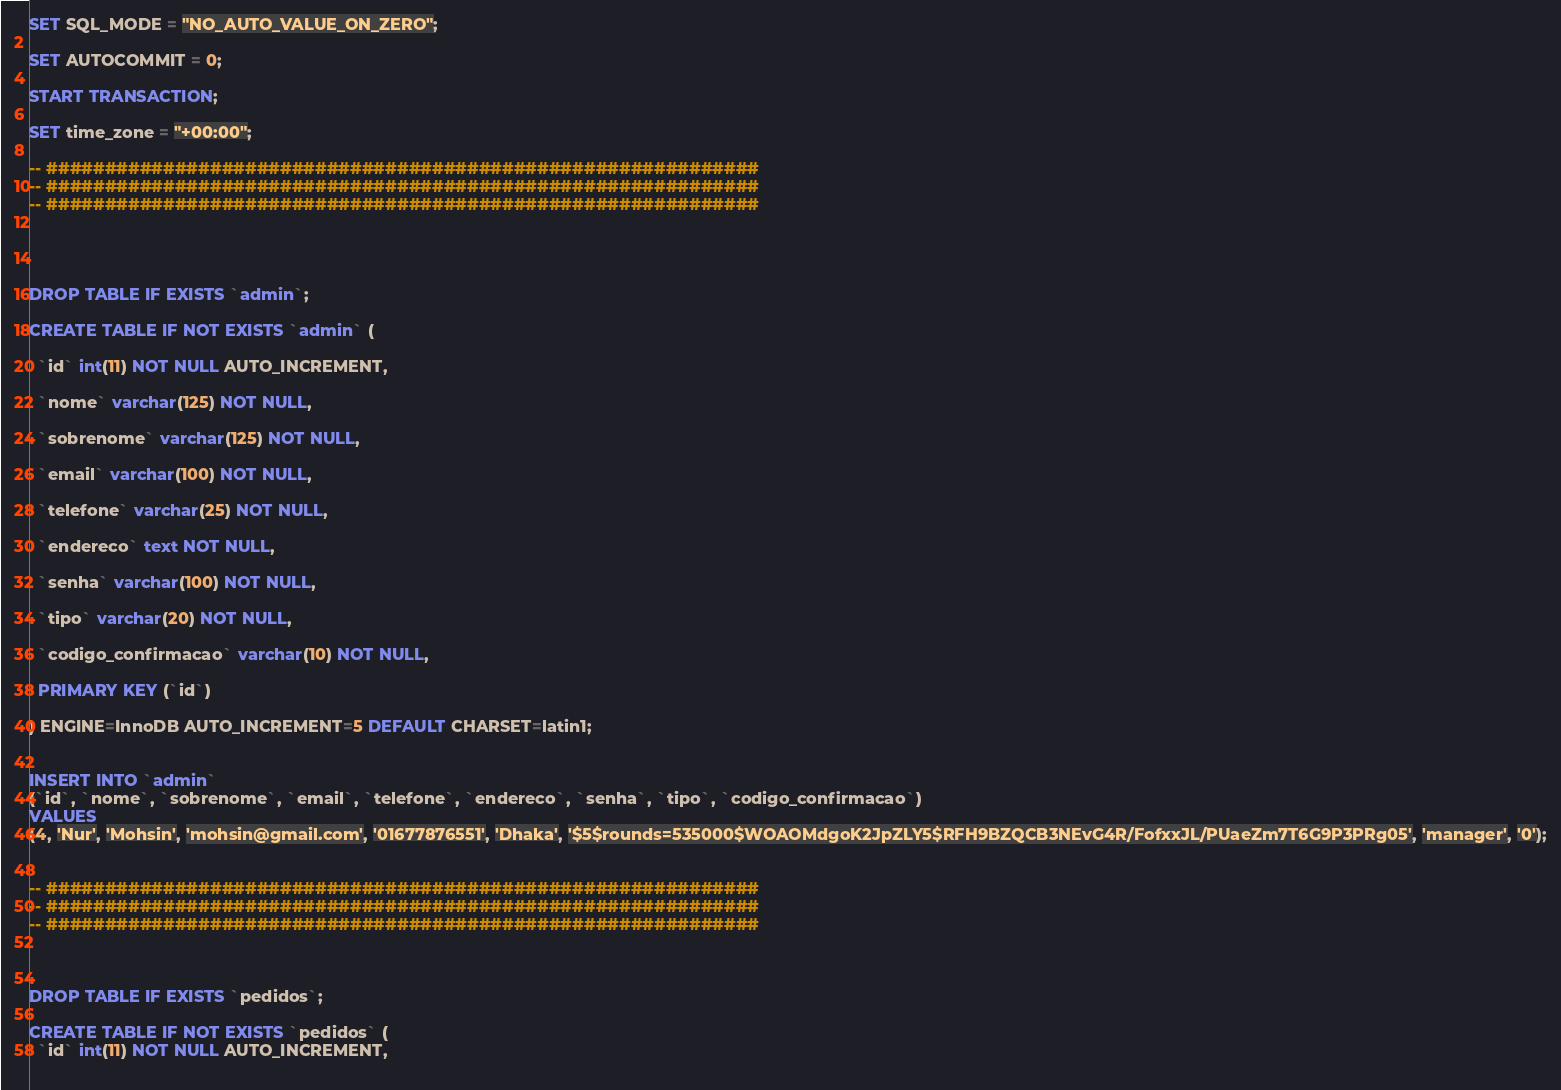<code> <loc_0><loc_0><loc_500><loc_500><_SQL_>SET SQL_MODE = "NO_AUTO_VALUE_ON_ZERO";

SET AUTOCOMMIT = 0;

START TRANSACTION;

SET time_zone = "+00:00";

-- #############################################################
-- #############################################################
-- #############################################################




DROP TABLE IF EXISTS `admin`;

CREATE TABLE IF NOT EXISTS `admin` (
  
  `id` int(11) NOT NULL AUTO_INCREMENT,
  
  `nome` varchar(125) NOT NULL,
  
  `sobrenome` varchar(125) NOT NULL,
  
  `email` varchar(100) NOT NULL,
  
  `telefone` varchar(25) NOT NULL,
  
  `endereco` text NOT NULL,
  
  `senha` varchar(100) NOT NULL,
  
  `tipo` varchar(20) NOT NULL,
  
  `codigo_confirmacao` varchar(10) NOT NULL,
  
  PRIMARY KEY (`id`)

) ENGINE=InnoDB AUTO_INCREMENT=5 DEFAULT CHARSET=latin1;


INSERT INTO `admin`
(`id`, `nome`, `sobrenome`, `email`, `telefone`, `endereco`, `senha`, `tipo`, `codigo_confirmacao`)
VALUES
(4, 'Nur', 'Mohsin', 'mohsin@gmail.com', '01677876551', 'Dhaka', '$5$rounds=535000$WOAOMdgoK2JpZLY5$RFH9BZQCB3NEvG4R/FofxxJL/PUaeZm7T6G9P3PRg05', 'manager', '0');


-- #############################################################
-- #############################################################
-- #############################################################



DROP TABLE IF EXISTS `pedidos`;

CREATE TABLE IF NOT EXISTS `pedidos` (
  `id` int(11) NOT NULL AUTO_INCREMENT,
  </code> 